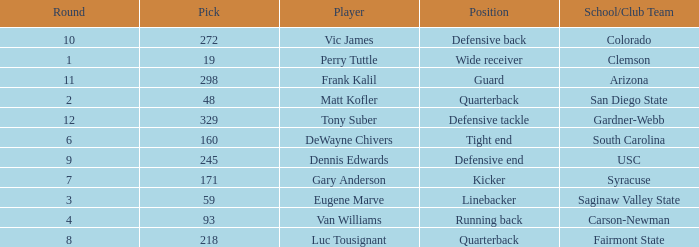Who plays linebacker? Eugene Marve. 